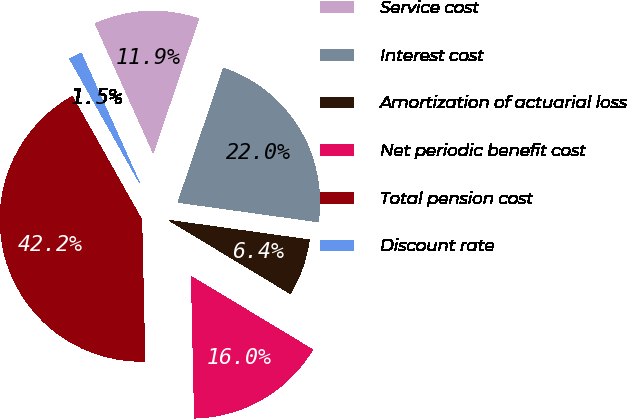Convert chart to OTSL. <chart><loc_0><loc_0><loc_500><loc_500><pie_chart><fcel>Service cost<fcel>Interest cost<fcel>Amortization of actuarial loss<fcel>Net periodic benefit cost<fcel>Total pension cost<fcel>Discount rate<nl><fcel>11.92%<fcel>22.0%<fcel>6.44%<fcel>16.0%<fcel>42.19%<fcel>1.45%<nl></chart> 